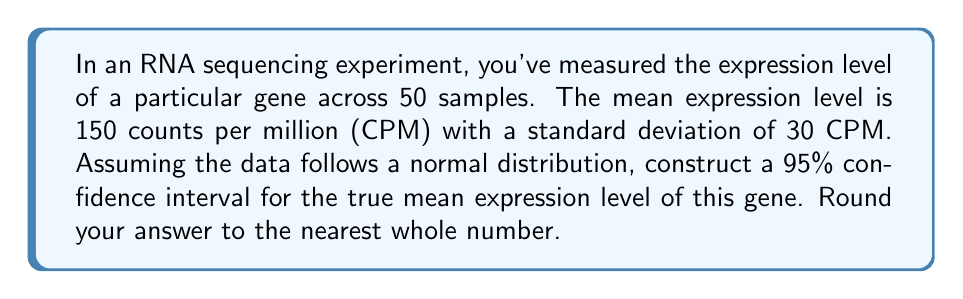Give your solution to this math problem. To construct a 95% confidence interval for the true mean expression level, we'll follow these steps:

1) The formula for a confidence interval is:

   $$\bar{x} \pm t_{\alpha/2, n-1} \cdot \frac{s}{\sqrt{n}}$$

   where $\bar{x}$ is the sample mean, $s$ is the sample standard deviation, $n$ is the sample size, and $t_{\alpha/2, n-1}$ is the t-value for a two-tailed test with $n-1$ degrees of freedom.

2) We know:
   $\bar{x} = 150$ CPM
   $s = 30$ CPM
   $n = 50$
   Confidence level = 95%, so $\alpha = 0.05$

3) For a 95% confidence interval with 49 degrees of freedom (n-1 = 49), the t-value is approximately 2.009 (from a t-table or calculator).

4) Now, let's calculate the margin of error:

   $$2.009 \cdot \frac{30}{\sqrt{50}} = 2.009 \cdot 4.24 = 8.52$$

5) Therefore, the confidence interval is:

   $$150 \pm 8.52$$

6) This gives us:
   Lower bound: $150 - 8.52 = 141.48$
   Upper bound: $150 + 8.52 = 158.52$

7) Rounding to the nearest whole number:
   Lower bound: 141
   Upper bound: 159
Answer: (141, 159) CPM 